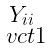Convert formula to latex. <formula><loc_0><loc_0><loc_500><loc_500>\begin{smallmatrix} Y _ { i i } \\ \ v c t { 1 } \end{smallmatrix}</formula> 